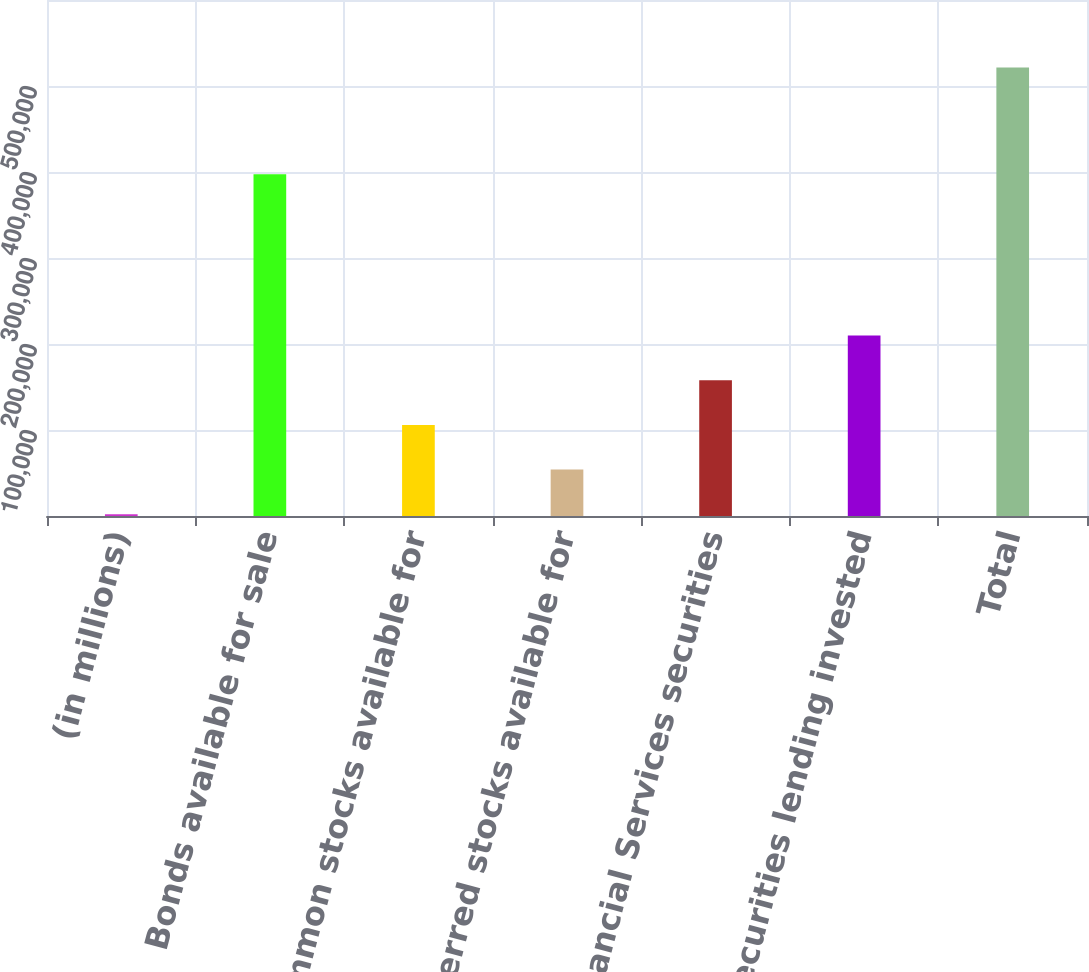Convert chart. <chart><loc_0><loc_0><loc_500><loc_500><bar_chart><fcel>(in millions)<fcel>Bonds available for sale<fcel>Common stocks available for<fcel>Preferred stocks available for<fcel>Financial Services securities<fcel>Securities lending invested<fcel>Total<nl><fcel>2007<fcel>397372<fcel>105925<fcel>53965.9<fcel>157884<fcel>209843<fcel>521596<nl></chart> 